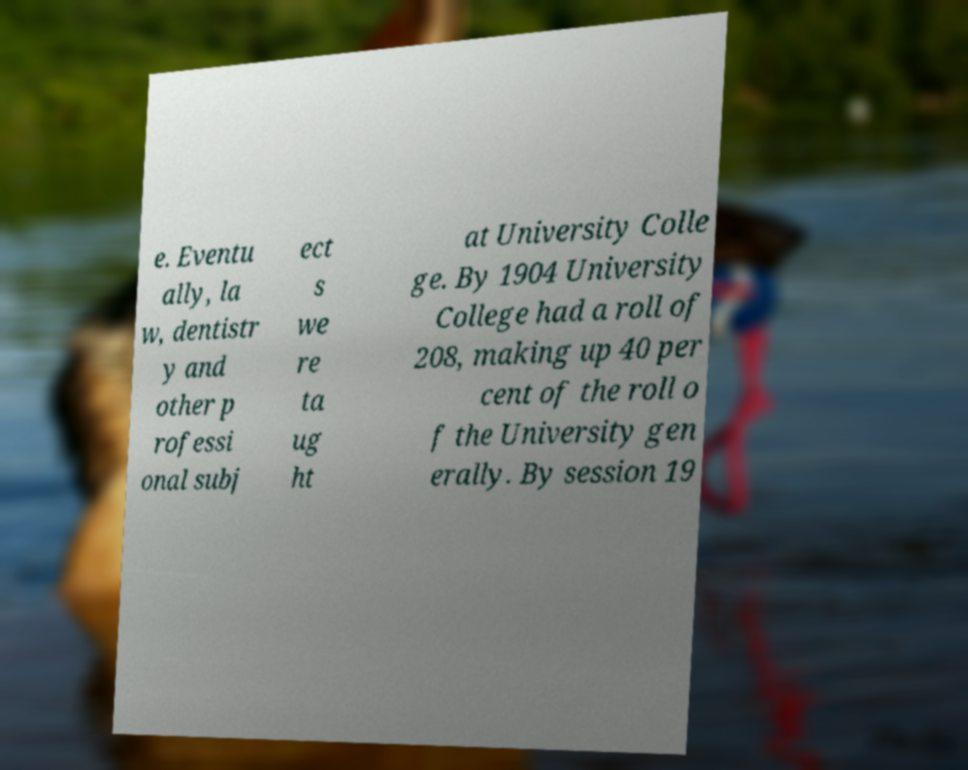For documentation purposes, I need the text within this image transcribed. Could you provide that? e. Eventu ally, la w, dentistr y and other p rofessi onal subj ect s we re ta ug ht at University Colle ge. By 1904 University College had a roll of 208, making up 40 per cent of the roll o f the University gen erally. By session 19 